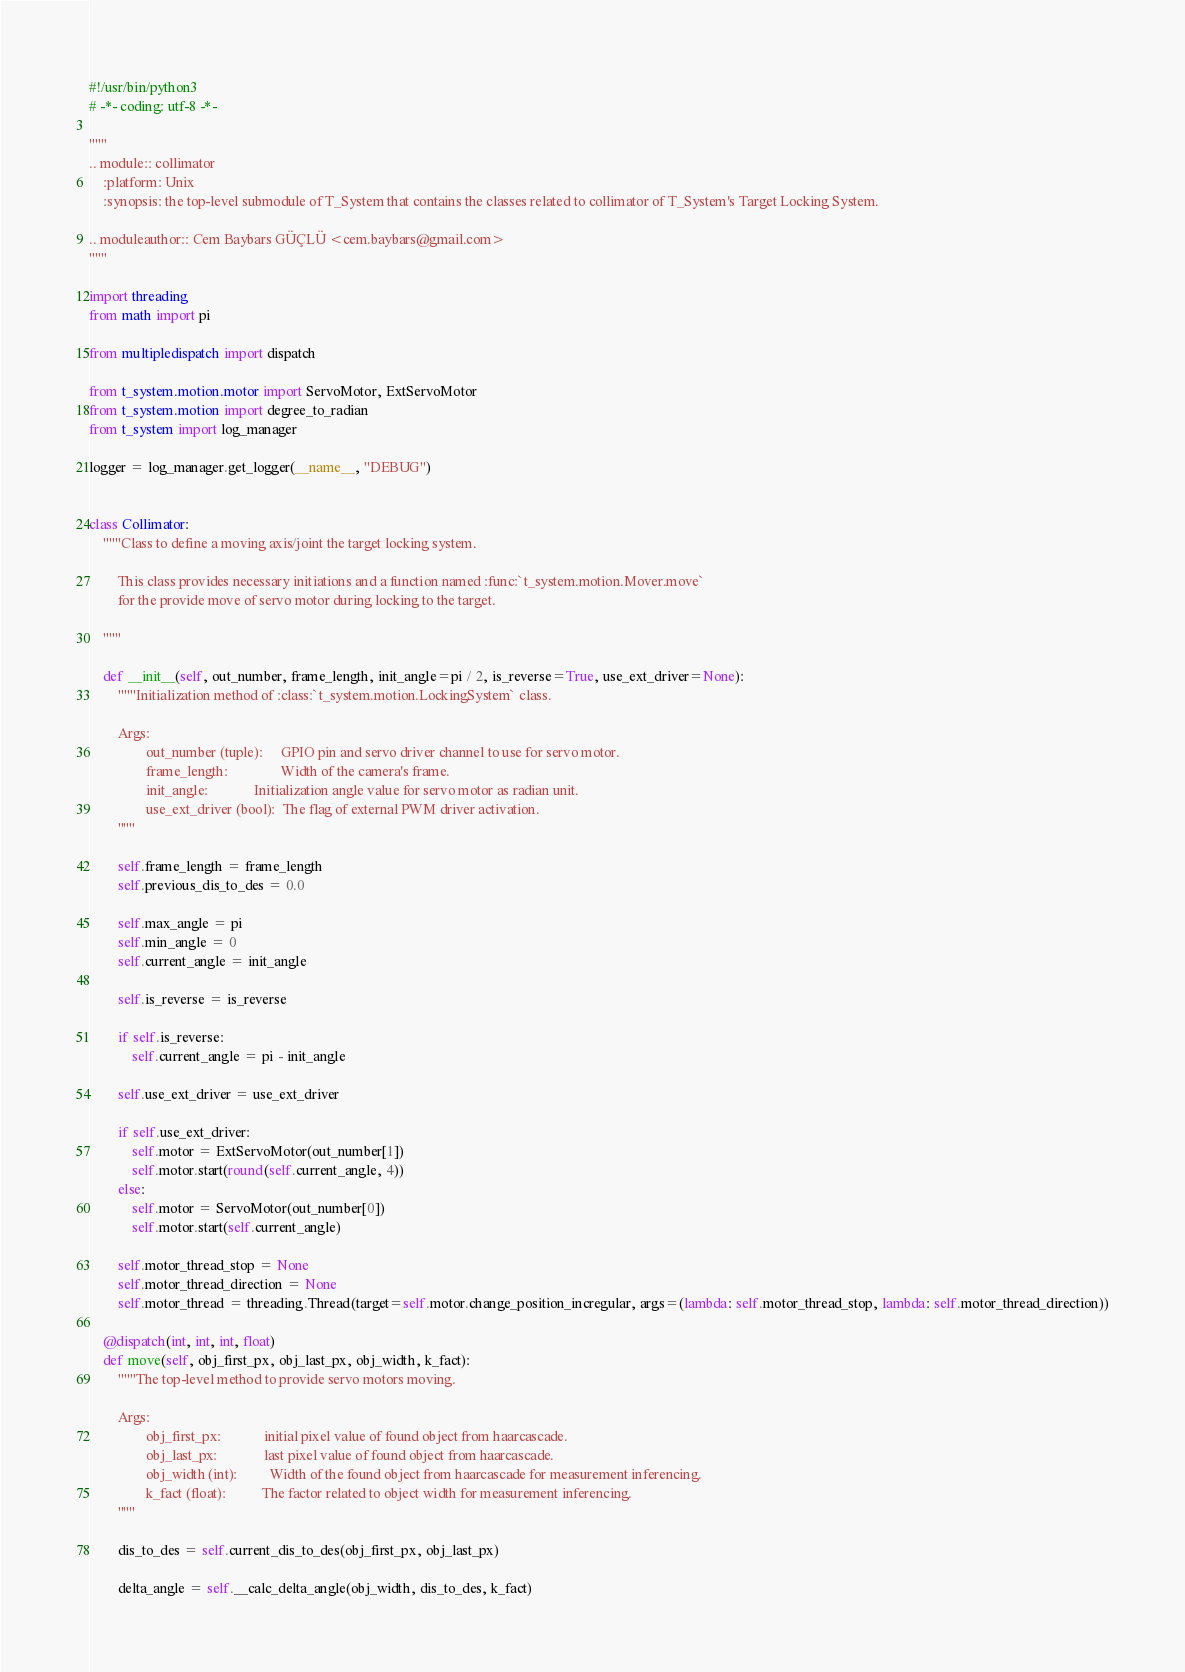<code> <loc_0><loc_0><loc_500><loc_500><_Python_>#!/usr/bin/python3
# -*- coding: utf-8 -*-

"""
.. module:: collimator
    :platform: Unix
    :synopsis: the top-level submodule of T_System that contains the classes related to collimator of T_System's Target Locking System.

.. moduleauthor:: Cem Baybars GÜÇLÜ <cem.baybars@gmail.com>
"""

import threading
from math import pi

from multipledispatch import dispatch

from t_system.motion.motor import ServoMotor, ExtServoMotor
from t_system.motion import degree_to_radian
from t_system import log_manager

logger = log_manager.get_logger(__name__, "DEBUG")


class Collimator:
    """Class to define a moving axis/joint the target locking system.

        This class provides necessary initiations and a function named :func:`t_system.motion.Mover.move`
        for the provide move of servo motor during locking to the target.

    """

    def __init__(self, out_number, frame_length, init_angle=pi / 2, is_reverse=True, use_ext_driver=None):
        """Initialization method of :class:`t_system.motion.LockingSystem` class.

        Args:
                out_number (tuple):     GPIO pin and servo driver channel to use for servo motor.
                frame_length:       	    Width of the camera's frame.
                init_angle:       	    Initialization angle value for servo motor as radian unit.
                use_ext_driver (bool):  The flag of external PWM driver activation.
        """

        self.frame_length = frame_length
        self.previous_dis_to_des = 0.0

        self.max_angle = pi
        self.min_angle = 0
        self.current_angle = init_angle

        self.is_reverse = is_reverse

        if self.is_reverse:
            self.current_angle = pi - init_angle

        self.use_ext_driver = use_ext_driver

        if self.use_ext_driver:
            self.motor = ExtServoMotor(out_number[1])
            self.motor.start(round(self.current_angle, 4))
        else:
            self.motor = ServoMotor(out_number[0])
            self.motor.start(self.current_angle)

        self.motor_thread_stop = None
        self.motor_thread_direction = None
        self.motor_thread = threading.Thread(target=self.motor.change_position_incregular, args=(lambda: self.motor_thread_stop, lambda: self.motor_thread_direction))

    @dispatch(int, int, int, float)
    def move(self, obj_first_px, obj_last_px, obj_width, k_fact):
        """The top-level method to provide servo motors moving.

        Args:
                obj_first_px:       	 initial pixel value of found object from haarcascade.
                obj_last_px:       	     last pixel value of found object from haarcascade.
                obj_width (int):         Width of the found object from haarcascade for measurement inferencing.
                k_fact (float):          The factor related to object width for measurement inferencing.
        """

        dis_to_des = self.current_dis_to_des(obj_first_px, obj_last_px)

        delta_angle = self.__calc_delta_angle(obj_width, dis_to_des, k_fact)
</code> 